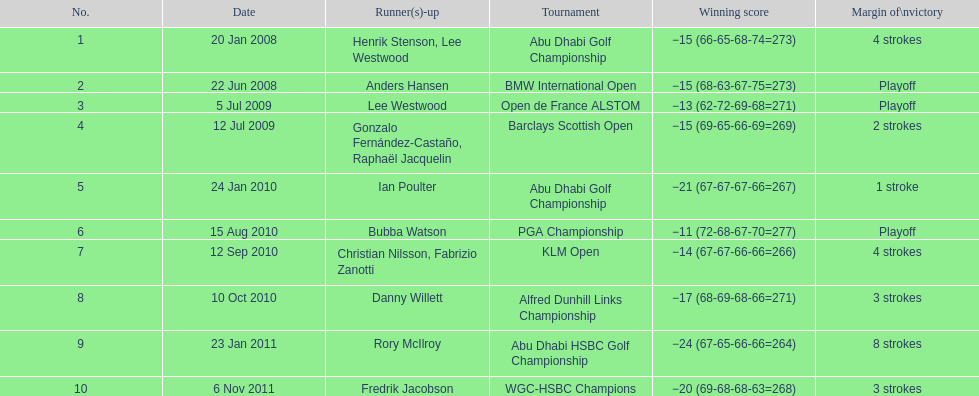How many more strokes were in the klm open than the barclays scottish open? 2 strokes. 